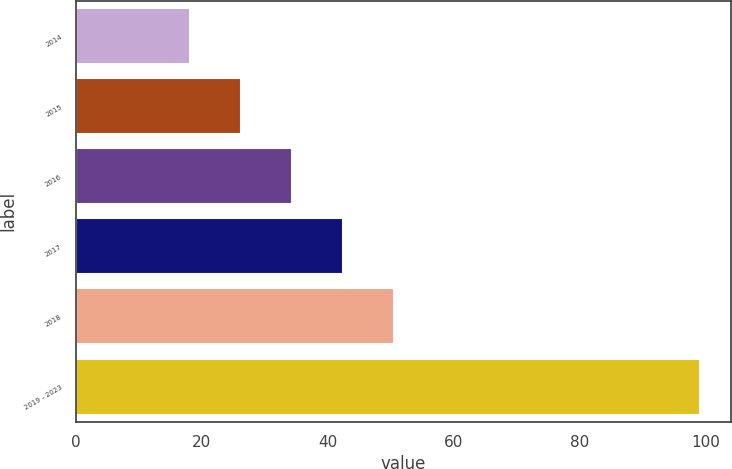Convert chart to OTSL. <chart><loc_0><loc_0><loc_500><loc_500><bar_chart><fcel>2014<fcel>2015<fcel>2016<fcel>2017<fcel>2018<fcel>2019 - 2023<nl><fcel>18.1<fcel>26.2<fcel>34.3<fcel>42.4<fcel>50.5<fcel>99.1<nl></chart> 